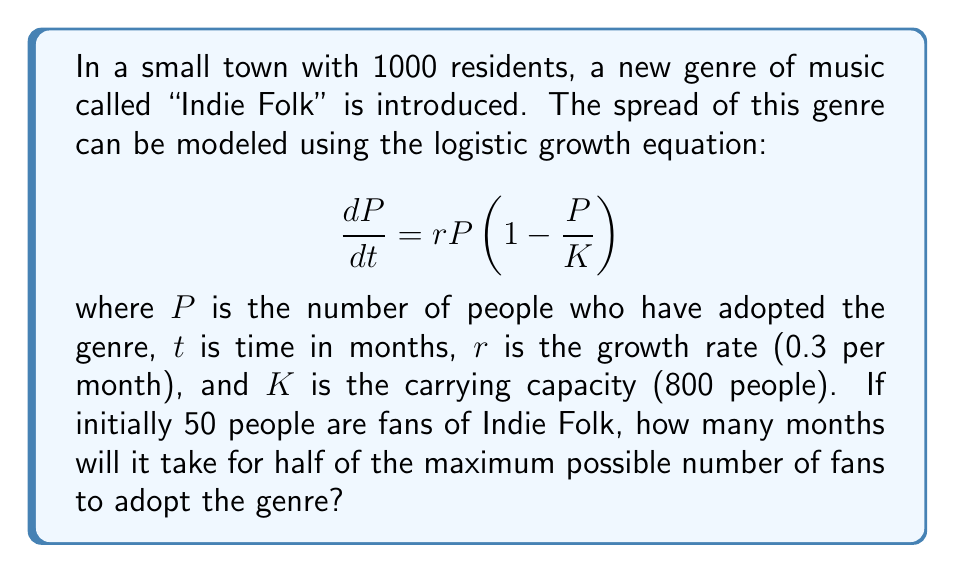Help me with this question. To solve this problem, we'll follow these steps:

1. Identify the key information:
   - Initial population: $P_0 = 50$
   - Carrying capacity: $K = 800$
   - Growth rate: $r = 0.3$ per month
   - Target population: $P_t = K/2 = 400$

2. Use the solution to the logistic growth equation:

   $$P(t) = \frac{K}{1 + (\frac{K}{P_0} - 1)e^{-rt}}$$

3. Substitute the known values and solve for $t$:

   $$400 = \frac{800}{1 + (\frac{800}{50} - 1)e^{-0.3t}}$$

4. Simplify:

   $$2 = 1 + 15e^{-0.3t}$$
   $$1 = 15e^{-0.3t}$$
   $$\frac{1}{15} = e^{-0.3t}$$

5. Take the natural logarithm of both sides:

   $$\ln(\frac{1}{15}) = -0.3t$$

6. Solve for $t$:

   $$t = -\frac{\ln(\frac{1}{15})}{0.3} = \frac{\ln(15)}{0.3} \approx 9.03$$

7. Round up to the nearest month:

   $t = 10$ months
Answer: 10 months 